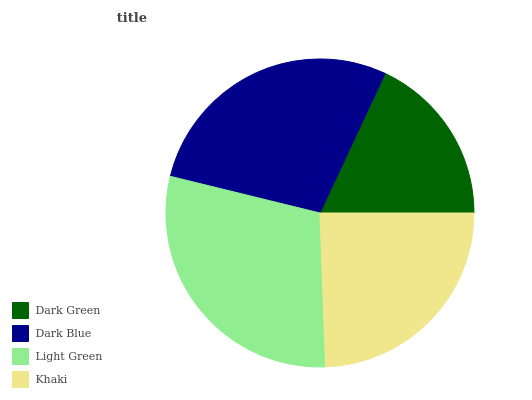Is Dark Green the minimum?
Answer yes or no. Yes. Is Light Green the maximum?
Answer yes or no. Yes. Is Dark Blue the minimum?
Answer yes or no. No. Is Dark Blue the maximum?
Answer yes or no. No. Is Dark Blue greater than Dark Green?
Answer yes or no. Yes. Is Dark Green less than Dark Blue?
Answer yes or no. Yes. Is Dark Green greater than Dark Blue?
Answer yes or no. No. Is Dark Blue less than Dark Green?
Answer yes or no. No. Is Dark Blue the high median?
Answer yes or no. Yes. Is Khaki the low median?
Answer yes or no. Yes. Is Light Green the high median?
Answer yes or no. No. Is Dark Green the low median?
Answer yes or no. No. 